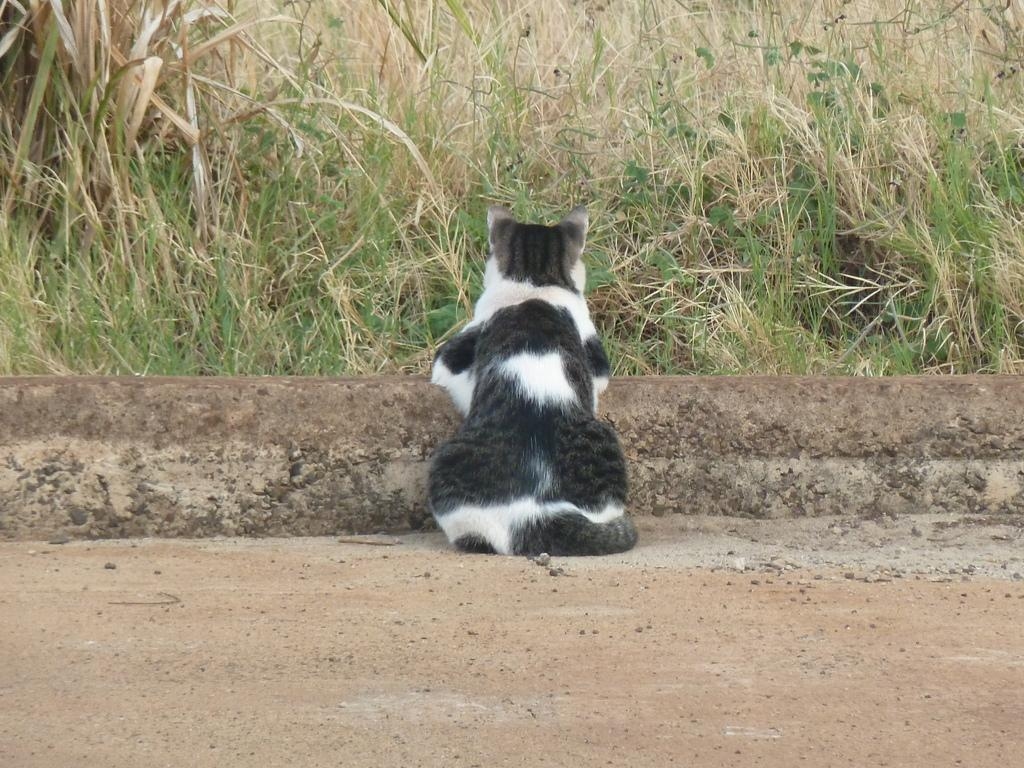What type of animal is in the image? There is a black and white cat in the image. Where is the cat located in relation to the wall? The cat is near a wall in the image. What can be seen in the background of the image? There is grass and plants visible in the background of the image. What type of plough is being used to cultivate the plants in the image? There is no plough present in the image; it features a black and white cat near a wall with grass and plants in the background. 